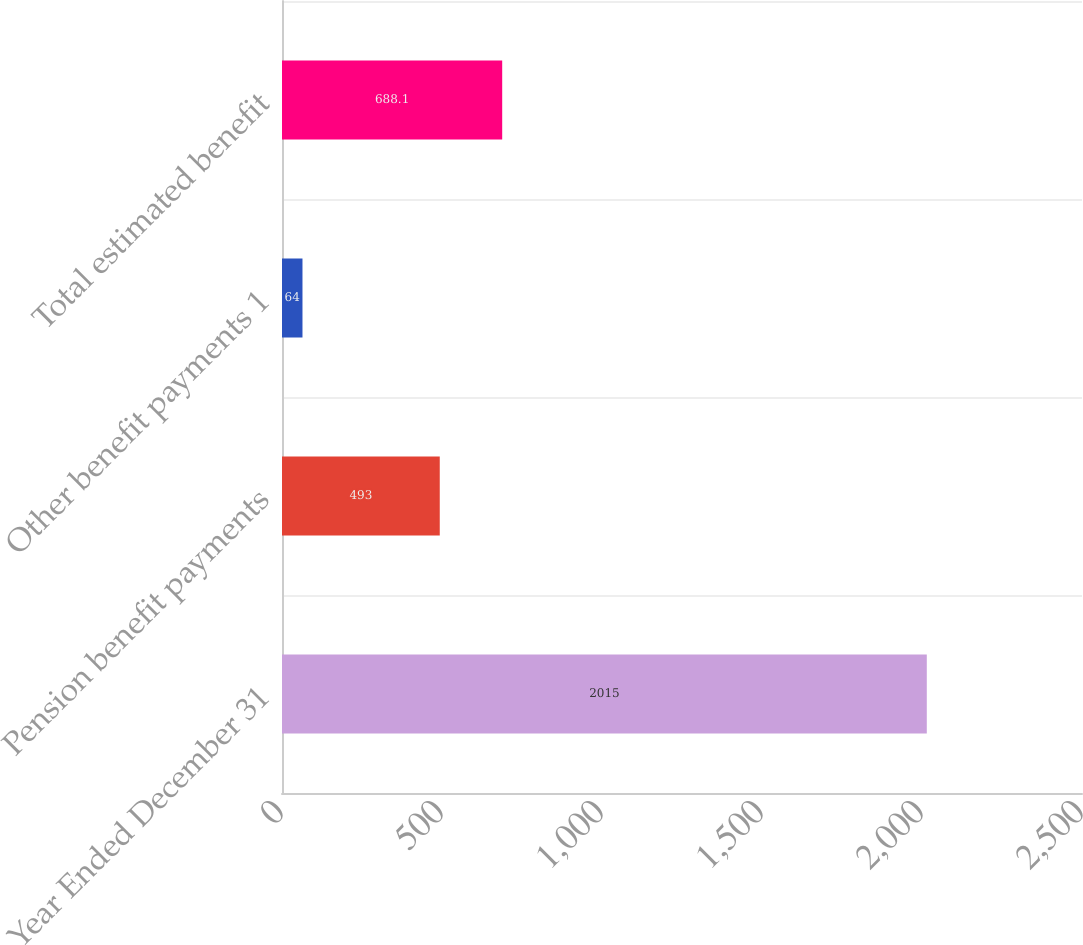Convert chart to OTSL. <chart><loc_0><loc_0><loc_500><loc_500><bar_chart><fcel>Year Ended December 31<fcel>Pension benefit payments<fcel>Other benefit payments 1<fcel>Total estimated benefit<nl><fcel>2015<fcel>493<fcel>64<fcel>688.1<nl></chart> 